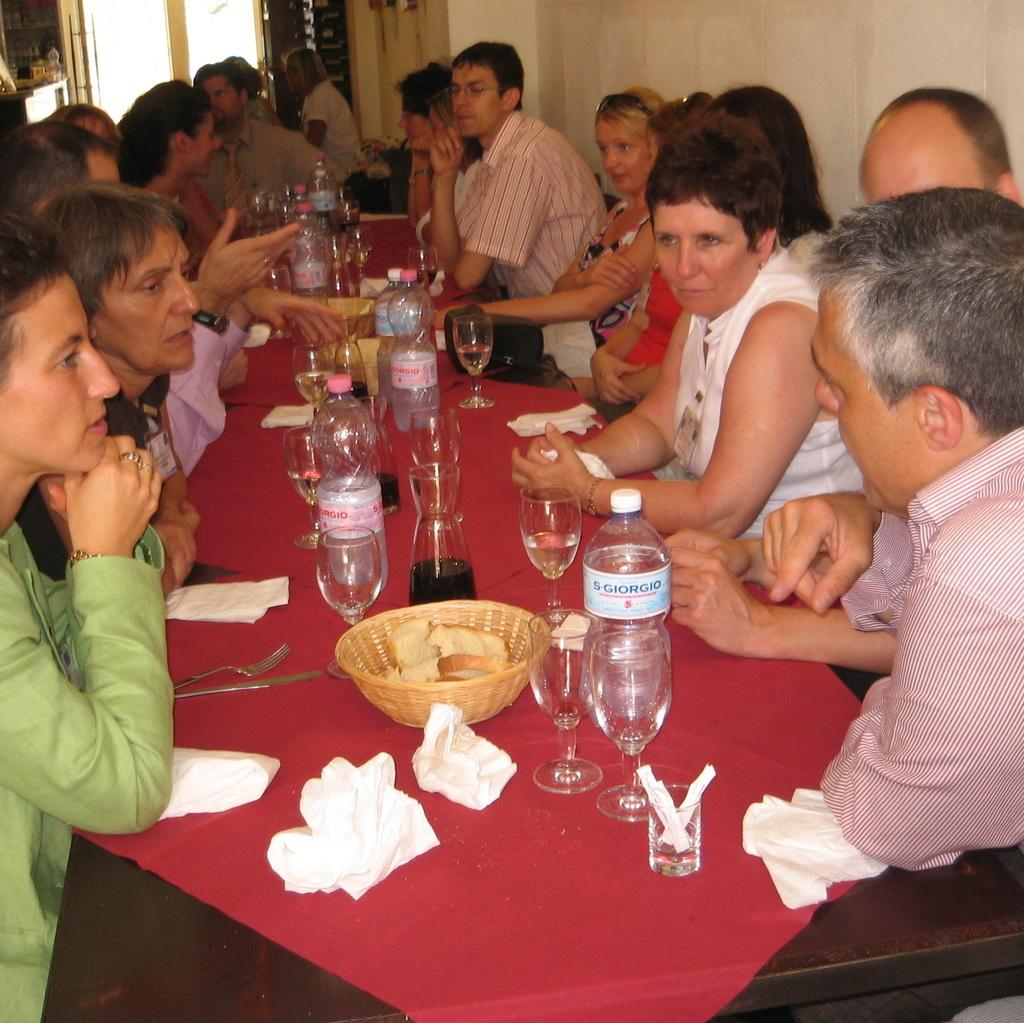How many people are in the image? There is a group of people in the image. What are the people doing in the image? The people are sitting on a chair, having a drink, and engaged in a conversation. What objects can be seen on the table in the image? A bottle, a glass, a basket, and tissues are present on the table. What type of song is the pig singing in the image? There is no pig or song present in the image. How many clams are visible on the table in the image? There are no clams present in the image. 